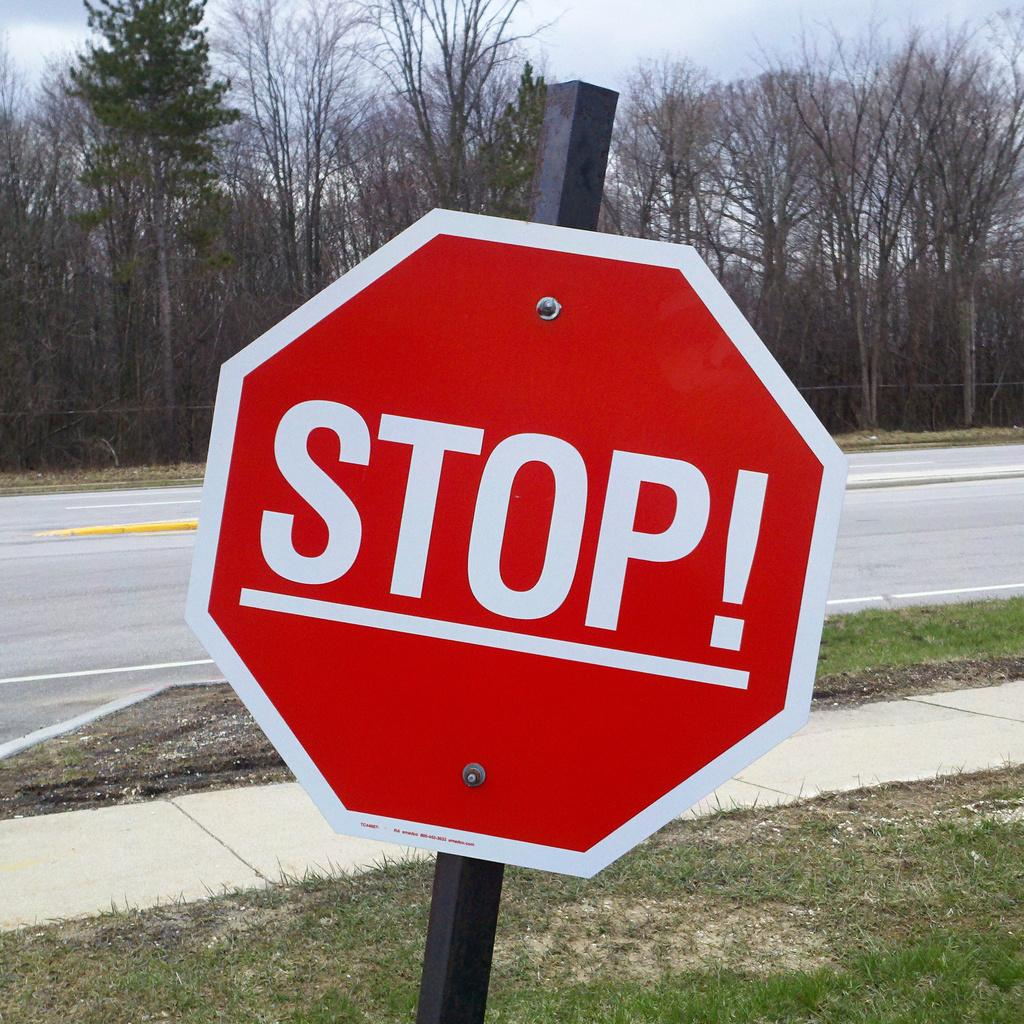<image>
Summarize the visual content of the image. A Stop sign which is leaning to the right. 